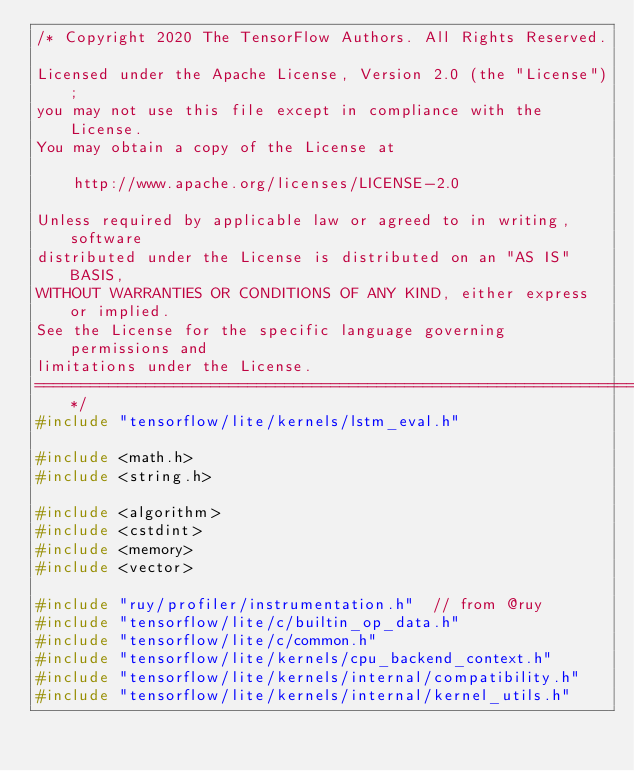<code> <loc_0><loc_0><loc_500><loc_500><_C++_>/* Copyright 2020 The TensorFlow Authors. All Rights Reserved.

Licensed under the Apache License, Version 2.0 (the "License");
you may not use this file except in compliance with the License.
You may obtain a copy of the License at

    http://www.apache.org/licenses/LICENSE-2.0

Unless required by applicable law or agreed to in writing, software
distributed under the License is distributed on an "AS IS" BASIS,
WITHOUT WARRANTIES OR CONDITIONS OF ANY KIND, either express or implied.
See the License for the specific language governing permissions and
limitations under the License.
==============================================================================*/
#include "tensorflow/lite/kernels/lstm_eval.h"

#include <math.h>
#include <string.h>

#include <algorithm>
#include <cstdint>
#include <memory>
#include <vector>

#include "ruy/profiler/instrumentation.h"  // from @ruy
#include "tensorflow/lite/c/builtin_op_data.h"
#include "tensorflow/lite/c/common.h"
#include "tensorflow/lite/kernels/cpu_backend_context.h"
#include "tensorflow/lite/kernels/internal/compatibility.h"
#include "tensorflow/lite/kernels/internal/kernel_utils.h"</code> 